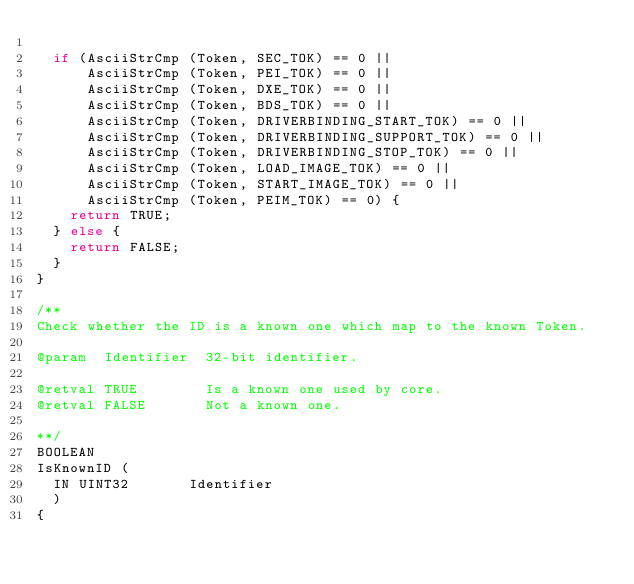Convert code to text. <code><loc_0><loc_0><loc_500><loc_500><_C_>
  if (AsciiStrCmp (Token, SEC_TOK) == 0 ||
      AsciiStrCmp (Token, PEI_TOK) == 0 ||
      AsciiStrCmp (Token, DXE_TOK) == 0 ||
      AsciiStrCmp (Token, BDS_TOK) == 0 ||
      AsciiStrCmp (Token, DRIVERBINDING_START_TOK) == 0 ||
      AsciiStrCmp (Token, DRIVERBINDING_SUPPORT_TOK) == 0 ||
      AsciiStrCmp (Token, DRIVERBINDING_STOP_TOK) == 0 ||
      AsciiStrCmp (Token, LOAD_IMAGE_TOK) == 0 ||
      AsciiStrCmp (Token, START_IMAGE_TOK) == 0 ||
      AsciiStrCmp (Token, PEIM_TOK) == 0) {
    return TRUE;
  } else {
    return FALSE;
  }
}

/**
Check whether the ID is a known one which map to the known Token.

@param  Identifier  32-bit identifier.

@retval TRUE        Is a known one used by core.
@retval FALSE       Not a known one.

**/
BOOLEAN
IsKnownID (
  IN UINT32       Identifier
  )
{</code> 